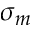<formula> <loc_0><loc_0><loc_500><loc_500>\sigma _ { m }</formula> 